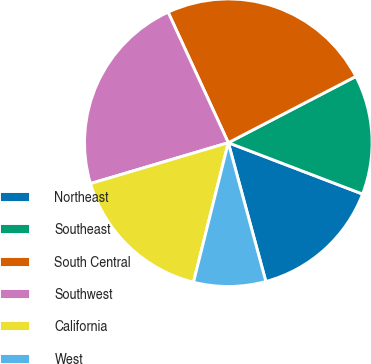Convert chart. <chart><loc_0><loc_0><loc_500><loc_500><pie_chart><fcel>Northeast<fcel>Southeast<fcel>South Central<fcel>Southwest<fcel>California<fcel>West<nl><fcel>14.98%<fcel>13.44%<fcel>24.25%<fcel>22.71%<fcel>16.52%<fcel>8.1%<nl></chart> 